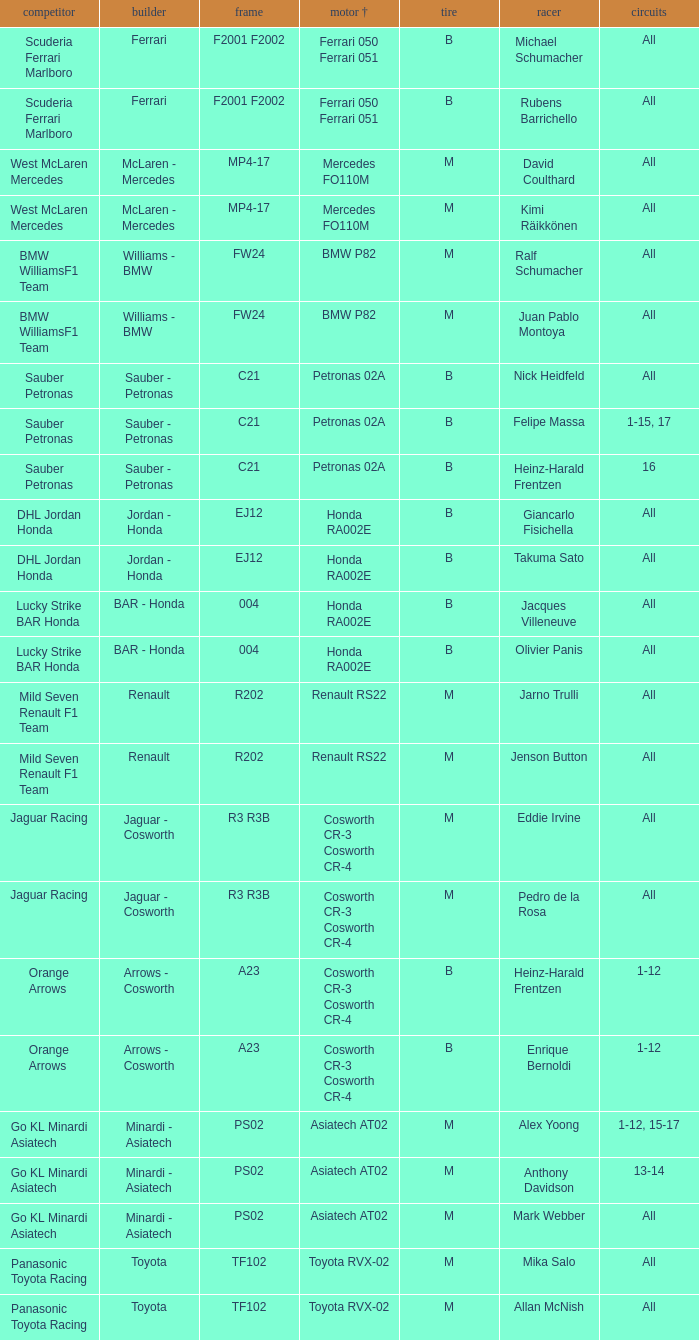In a scenario where all rounds are done, the tire is m, and david coulthard is the driver, what is the engine? Mercedes FO110M. 